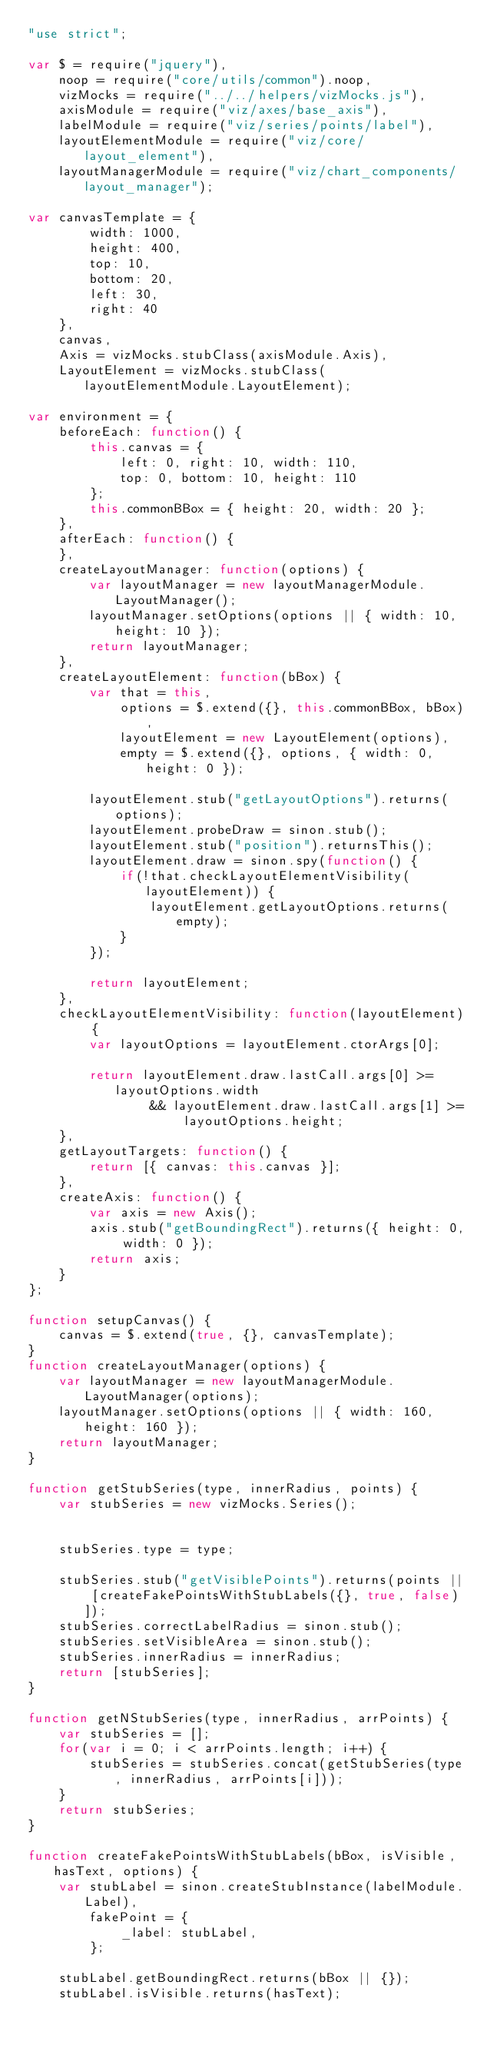<code> <loc_0><loc_0><loc_500><loc_500><_JavaScript_>"use strict";

var $ = require("jquery"),
    noop = require("core/utils/common").noop,
    vizMocks = require("../../helpers/vizMocks.js"),
    axisModule = require("viz/axes/base_axis"),
    labelModule = require("viz/series/points/label"),
    layoutElementModule = require("viz/core/layout_element"),
    layoutManagerModule = require("viz/chart_components/layout_manager");

var canvasTemplate = {
        width: 1000,
        height: 400,
        top: 10,
        bottom: 20,
        left: 30,
        right: 40
    },
    canvas,
    Axis = vizMocks.stubClass(axisModule.Axis),
    LayoutElement = vizMocks.stubClass(layoutElementModule.LayoutElement);

var environment = {
    beforeEach: function() {
        this.canvas = {
            left: 0, right: 10, width: 110,
            top: 0, bottom: 10, height: 110
        };
        this.commonBBox = { height: 20, width: 20 };
    },
    afterEach: function() {
    },
    createLayoutManager: function(options) {
        var layoutManager = new layoutManagerModule.LayoutManager();
        layoutManager.setOptions(options || { width: 10, height: 10 });
        return layoutManager;
    },
    createLayoutElement: function(bBox) {
        var that = this,
            options = $.extend({}, this.commonBBox, bBox),
            layoutElement = new LayoutElement(options),
            empty = $.extend({}, options, { width: 0, height: 0 });

        layoutElement.stub("getLayoutOptions").returns(options);
        layoutElement.probeDraw = sinon.stub();
        layoutElement.stub("position").returnsThis();
        layoutElement.draw = sinon.spy(function() {
            if(!that.checkLayoutElementVisibility(layoutElement)) {
                layoutElement.getLayoutOptions.returns(empty);
            }
        });

        return layoutElement;
    },
    checkLayoutElementVisibility: function(layoutElement) {
        var layoutOptions = layoutElement.ctorArgs[0];

        return layoutElement.draw.lastCall.args[0] >= layoutOptions.width
                && layoutElement.draw.lastCall.args[1] >= layoutOptions.height;
    },
    getLayoutTargets: function() {
        return [{ canvas: this.canvas }];
    },
    createAxis: function() {
        var axis = new Axis();
        axis.stub("getBoundingRect").returns({ height: 0, width: 0 });
        return axis;
    }
};

function setupCanvas() {
    canvas = $.extend(true, {}, canvasTemplate);
}
function createLayoutManager(options) {
    var layoutManager = new layoutManagerModule.LayoutManager(options);
    layoutManager.setOptions(options || { width: 160, height: 160 });
    return layoutManager;
}

function getStubSeries(type, innerRadius, points) {
    var stubSeries = new vizMocks.Series();


    stubSeries.type = type;

    stubSeries.stub("getVisiblePoints").returns(points || [createFakePointsWithStubLabels({}, true, false)]);
    stubSeries.correctLabelRadius = sinon.stub();
    stubSeries.setVisibleArea = sinon.stub();
    stubSeries.innerRadius = innerRadius;
    return [stubSeries];
}

function getNStubSeries(type, innerRadius, arrPoints) {
    var stubSeries = [];
    for(var i = 0; i < arrPoints.length; i++) {
        stubSeries = stubSeries.concat(getStubSeries(type, innerRadius, arrPoints[i]));
    }
    return stubSeries;
}

function createFakePointsWithStubLabels(bBox, isVisible, hasText, options) {
    var stubLabel = sinon.createStubInstance(labelModule.Label),
        fakePoint = {
            _label: stubLabel,
        };

    stubLabel.getBoundingRect.returns(bBox || {});
    stubLabel.isVisible.returns(hasText);</code> 